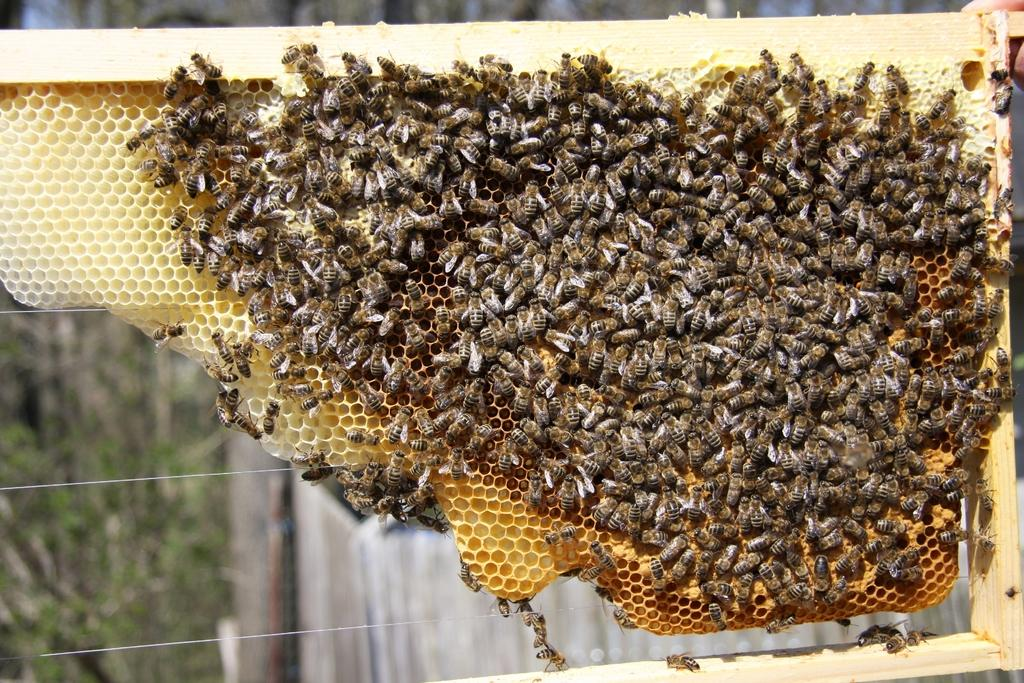What insects can be seen in the image? There are honey bees on the honeycomb in the image. What can be seen in the background of the image? There are wires and plants visible in the background of the image. What type of clover is being sorted by the letters in the image? There is no clover or letters present in the image. 